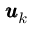<formula> <loc_0><loc_0><loc_500><loc_500>\pm b { u } _ { k }</formula> 